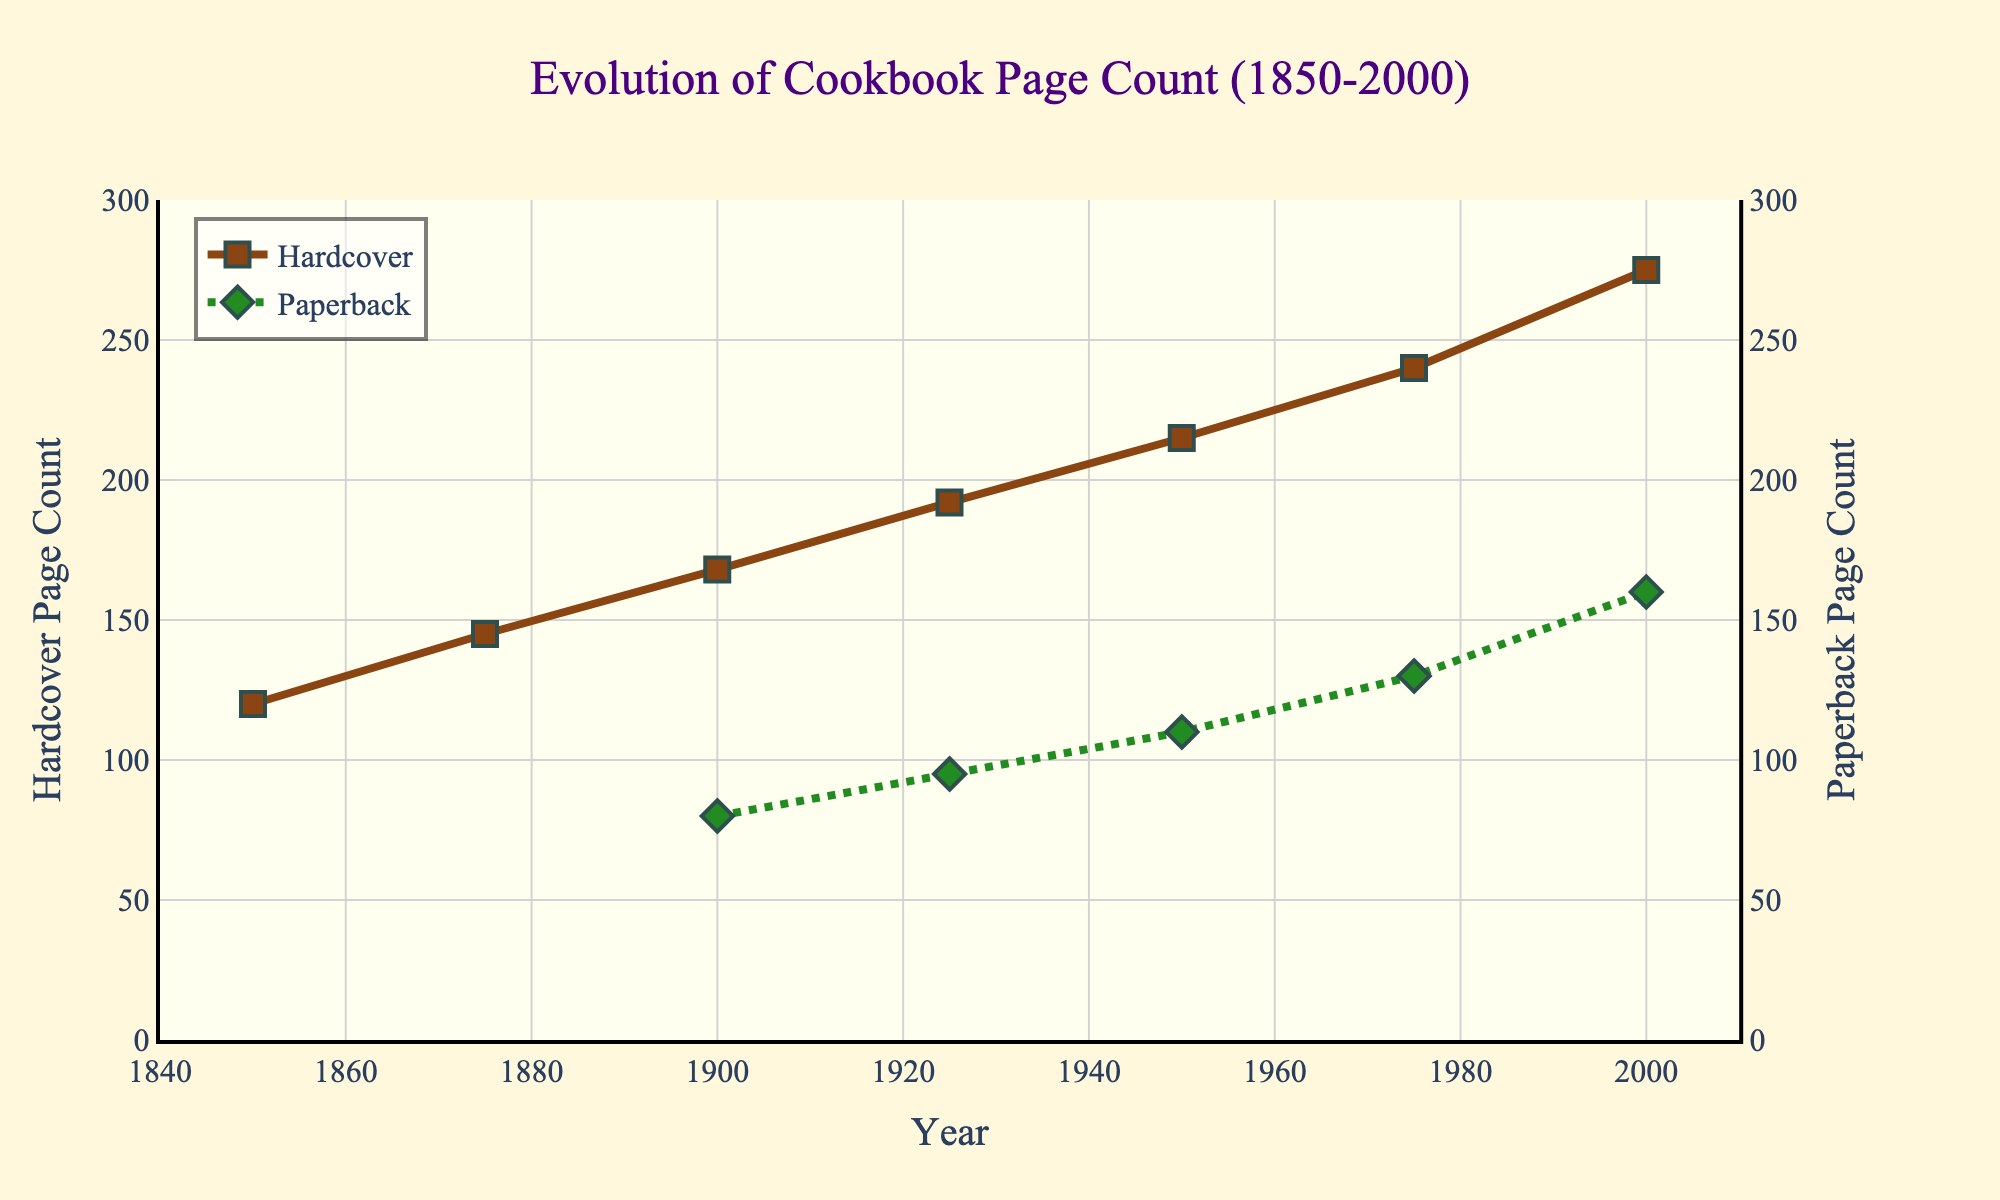What is the page count of hardcovers in 1950? From the figure, find the point corresponding to the year 1950 on the x-axis and check the y-value for hardcover.
Answer: 215 What is the difference in page count between hardcover and paperback books in 2000? Locate the page counts for both hardcover and paperback in 2000 from the figure. Hardcover is 275 and paperback is 160. Subtract the paperback count from the hardcover count (275 - 160).
Answer: 115 How did the average page count of paperback books change from 1900 to 2000? Check the page counts for paperbacks in 1900 and 2000 from the figure. Paperback page count was 80 in 1900 and 160 in 2000. The change is calculated as 160 - 80.
Answer: Increased by 80 Which format saw the greatest increase in average page count from 1950 to 2000? Look at the page counts for both hardcover and paperback in 1950 and 2000. Calculate the increase for hardcovers (275 - 215 = 60) and for paperbacks (160 - 110 = 50). Compare the two increases.
Answer: Hardcover What is the trend of hardcover page counts between 1850 and 2000? Observe the plot line for hardcover from 1850 to 2000. The line is generally increasing over time, indicating a rising trend.
Answer: Increasing How many years did it take for hardcover page counts to increase from 120 to 215 pages? Find the starting point where the hardcover page count is 120 (1850) and the ending point where it is 215 (1950). Subtract the starting year from the ending year (1950 - 1850).
Answer: 100 years Which edition starts showing data points first, hardcover or paperback? Locate the first data point for both hardcover and paperback on the x-axis. Hardcover starts in 1850 while paperback starts in 1900.
Answer: Hardcover By how much did the hardcover page count increase from 1925 to 1950? Locate the hardcover page count values in 1925 (192 pages) and 1950 (215 pages). Calculate the increase (215 - 192).
Answer: 23 pages Which format exceeded 130 pages first, hardcover or paperback? Identify the year each format first exceeded 130 pages. Hardcover exceeds 130 pages around 1875, while paperback exceeds 130 pages around 1975.
Answer: Hardcover Does the gap between hardcover and paperback page counts increase or decrease over time? Observe the difference between hardcover and paperback page counts at various years. The gap appears to increase from 1900 (88 pages) to 2000 (115 pages) as the distance between the lines widens.
Answer: Increase 